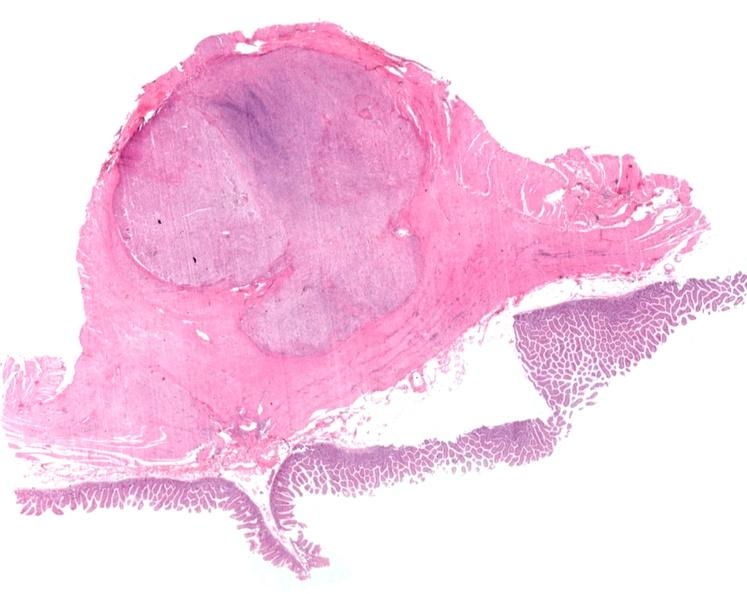s fibroma present?
Answer the question using a single word or phrase. No 